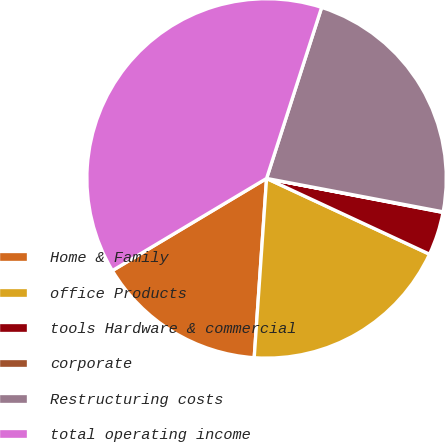Convert chart to OTSL. <chart><loc_0><loc_0><loc_500><loc_500><pie_chart><fcel>Home & Family<fcel>office Products<fcel>tools Hardware & commercial<fcel>corporate<fcel>Restructuring costs<fcel>total operating income<nl><fcel>15.33%<fcel>19.17%<fcel>3.9%<fcel>0.05%<fcel>23.02%<fcel>38.53%<nl></chart> 